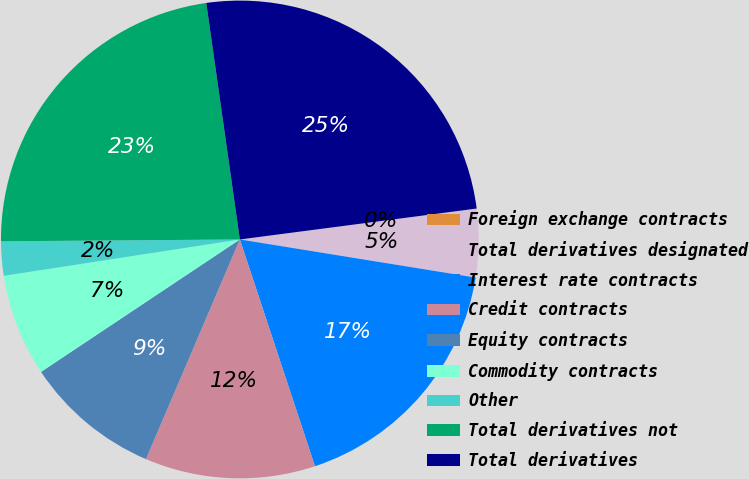Convert chart. <chart><loc_0><loc_0><loc_500><loc_500><pie_chart><fcel>Foreign exchange contracts<fcel>Total derivatives designated<fcel>Interest rate contracts<fcel>Credit contracts<fcel>Equity contracts<fcel>Commodity contracts<fcel>Other<fcel>Total derivatives not<fcel>Total derivatives<nl><fcel>0.01%<fcel>4.61%<fcel>17.36%<fcel>11.52%<fcel>9.22%<fcel>6.92%<fcel>2.31%<fcel>22.88%<fcel>25.18%<nl></chart> 